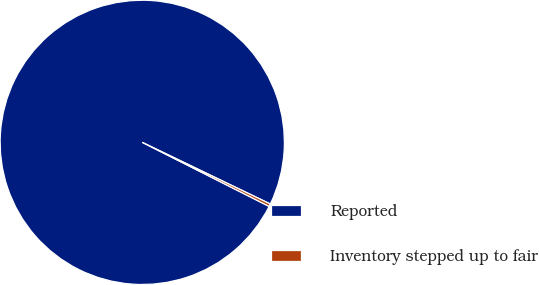Convert chart to OTSL. <chart><loc_0><loc_0><loc_500><loc_500><pie_chart><fcel>Reported<fcel>Inventory stepped up to fair<nl><fcel>99.7%<fcel>0.3%<nl></chart> 